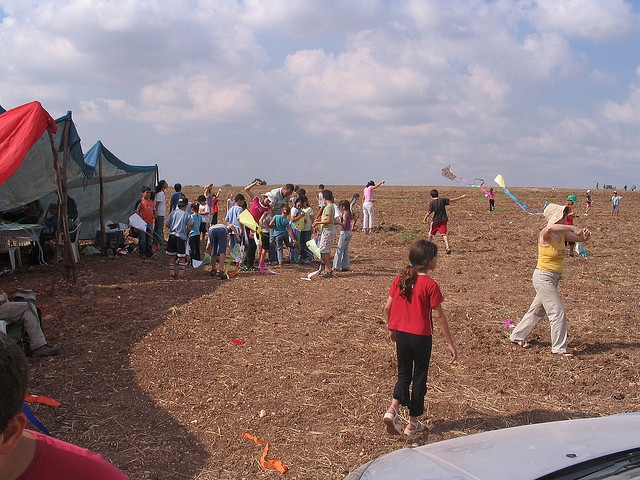Describe the objects in this image and their specific colors. I can see people in lavender, black, darkgray, and gray tones, car in lavender, darkgray, and black tones, people in lavender, black, maroon, and brown tones, people in lavender, maroon, black, and brown tones, and people in lavender, darkgray, tan, gray, and lightgray tones in this image. 